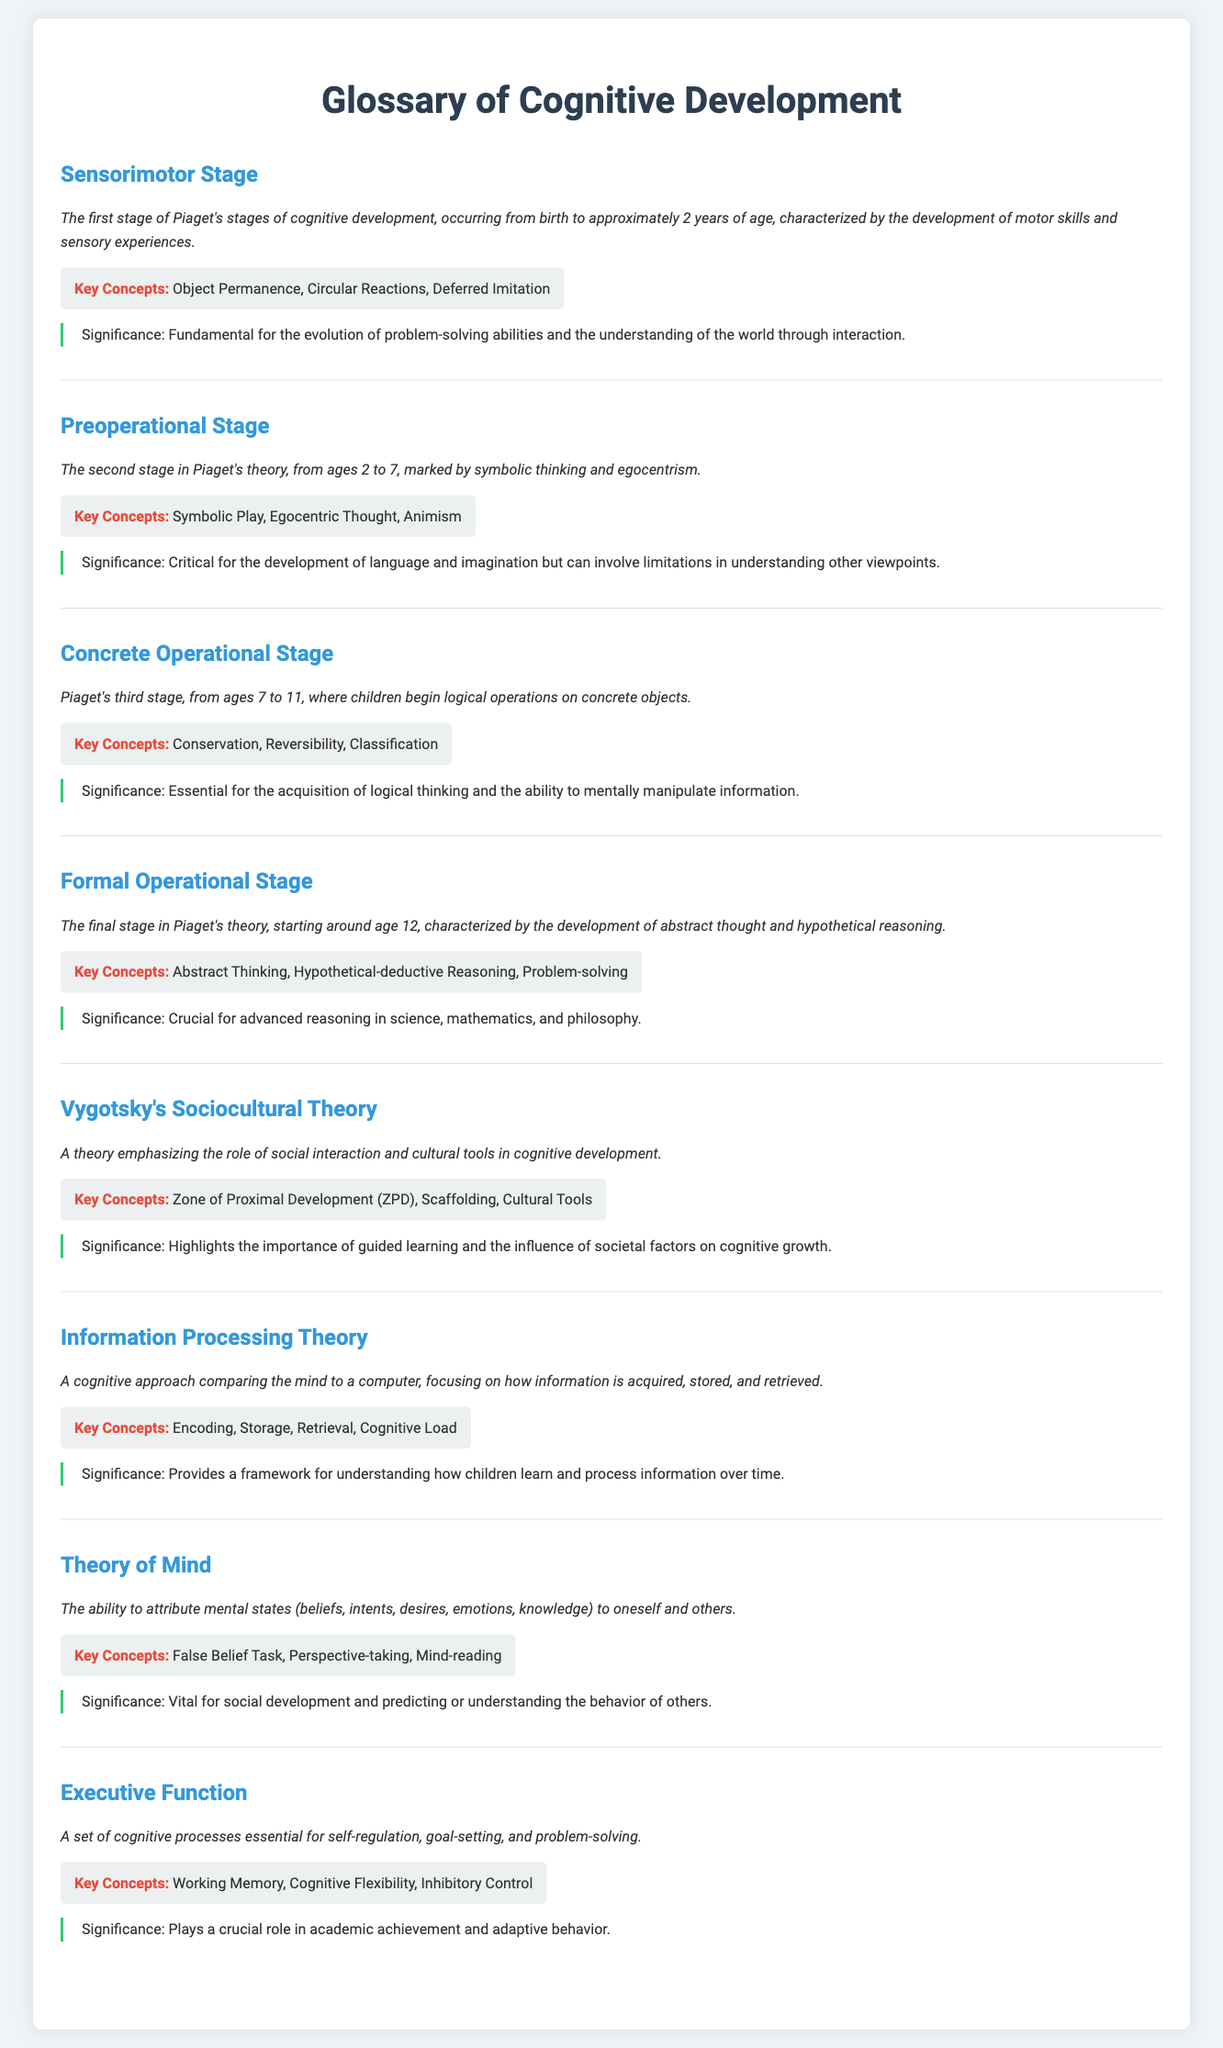What is the first stage of Piaget's cognitive development? The first stage is defined in the document as the Sensorimotor Stage, which occurs from birth to approximately 2 years of age.
Answer: Sensorimotor Stage What age range does the Preoperational Stage cover? The document states that the Preoperational Stage occurs from ages 2 to 7.
Answer: 2 to 7 What key concept is associated with the Formal Operational Stage? The document lists abstract thinking as a key concept of the Formal Operational Stage.
Answer: Abstract Thinking What is the significance of Vygotsky's Sociocultural Theory? The significance highlighted in the document is the importance of guided learning and societal factors on cognitive growth.
Answer: Guided learning and societal factors How does Information Processing Theory compare the mind? According to the document, Information Processing Theory compares the mind to a computer.
Answer: To a computer What ability is defined by the Theory of Mind? The ability defined is the attribution of mental states to oneself and others, as stated in the document.
Answer: Attribution of mental states What cognitive processes are essential for Executive Function? The document lists working memory, cognitive flexibility, and inhibitory control as essential cognitive processes.
Answer: Working memory, cognitive flexibility, inhibitory control What concept is highlighted in the significance of the Concrete Operational Stage? The significance notes the acquisition of logical thinking is highlighted for the Concrete Operational Stage.
Answer: Logical thinking 